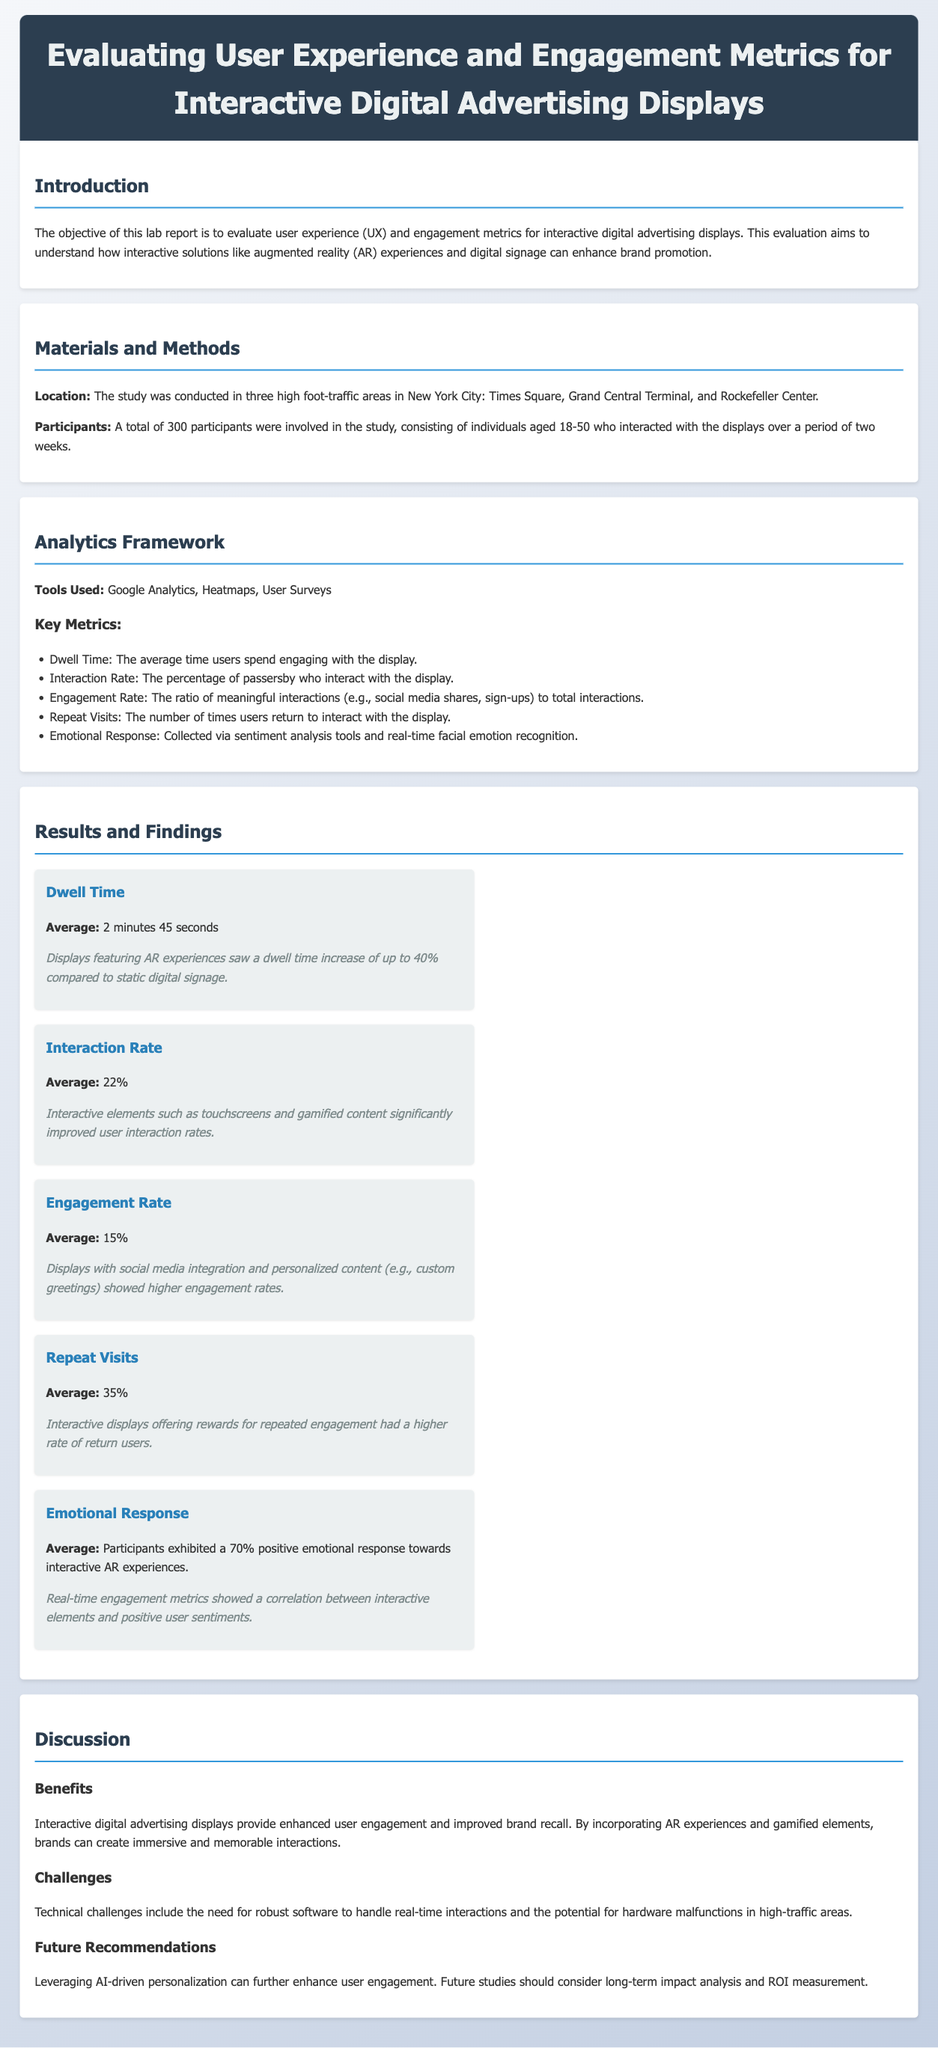What is the average dwell time? The average dwell time is mentioned in the results section, which is 2 minutes 45 seconds.
Answer: 2 minutes 45 seconds What is the interaction rate? The interaction rate is found in the results section as the average percentage of users who interact with the display, which is 22%.
Answer: 22% How many participants were involved in the study? The number of participants is specified in the materials and methods section, stating that there were 300 participants.
Answer: 300 What are the two tools used for analytics? The tools used for analytics are listed in the analytics framework section, and two of them are Google Analytics and Heatmaps.
Answer: Google Analytics, Heatmaps What is the emotional response percentage towards interactive AR experiences? The emotional response percentage is provided in the results section, indicating that participants exhibited a 70% positive emotional response.
Answer: 70% What challenge is mentioned in the discussion? A challenge discussed relates to technical issues, specifically the need for robust software to handle real-time interactions.
Answer: Technical challenges What is a future recommendation mentioned in the report? The report suggests leveraging AI-driven personalization to enhance user engagement in the future recommendations section.
Answer: AI-driven personalization What is the average engagement rate? The average engagement rate mentioned in the results section is the ratio of meaningful interactions to total interactions, which is 15%.
Answer: 15% What location was the study conducted? The study location is specified in the materials and methods section, stating that it was conducted in high foot-traffic areas in New York City.
Answer: New York City 